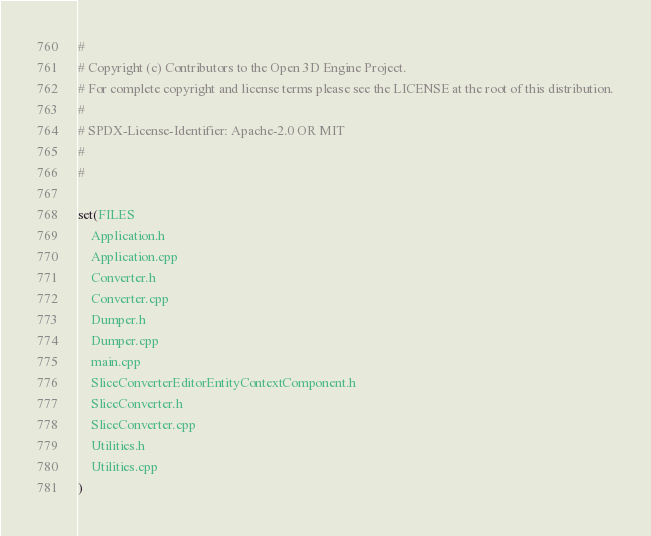Convert code to text. <code><loc_0><loc_0><loc_500><loc_500><_CMake_>#
# Copyright (c) Contributors to the Open 3D Engine Project.
# For complete copyright and license terms please see the LICENSE at the root of this distribution.
#
# SPDX-License-Identifier: Apache-2.0 OR MIT
#
#

set(FILES
    Application.h
    Application.cpp
    Converter.h
    Converter.cpp
    Dumper.h
    Dumper.cpp
    main.cpp
    SliceConverterEditorEntityContextComponent.h
    SliceConverter.h
    SliceConverter.cpp
    Utilities.h
    Utilities.cpp
)
</code> 